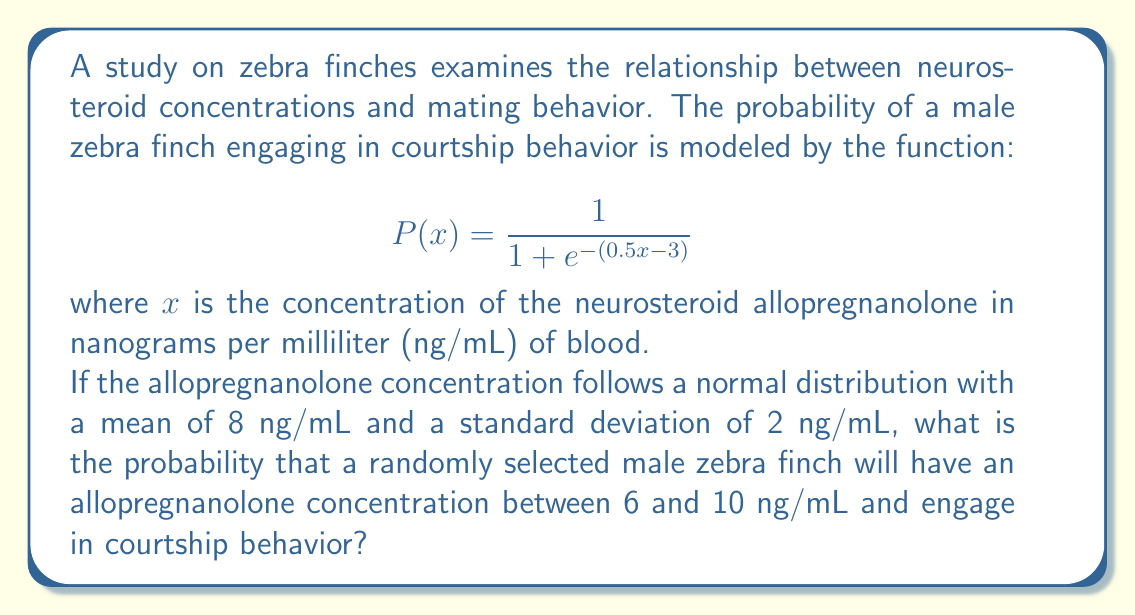Help me with this question. To solve this problem, we need to break it down into steps:

1) First, we need to find the probability that the allopregnanolone concentration is between 6 and 10 ng/mL.

2) Then, we need to calculate the probability of courtship behavior for concentrations of 6 and 10 ng/mL.

3) Finally, we'll use these probabilities to estimate the overall probability.

Step 1: Probability of concentration between 6 and 10 ng/mL

For a normal distribution, we can use the z-score formula:
$$z = \frac{x - \mu}{\sigma}$$

For x = 6: $z_1 = \frac{6 - 8}{2} = -1$
For x = 10: $z_2 = \frac{10 - 8}{2} = 1$

Using a standard normal distribution table or calculator:
P(-1 < Z < 1) ≈ 0.6827

Step 2: Probability of courtship behavior

For x = 6:
$$P(6) = \frac{1}{1 + e^{-(0.5 \cdot 6 - 3)}} \approx 0.5$$

For x = 10:
$$P(10) = \frac{1}{1 + e^{-(0.5 \cdot 10 - 3)}} \approx 0.9241$$

Step 3: Estimating overall probability

We can estimate the probability by taking the average of P(6) and P(10) and multiplying by the probability from step 1:

$$(\frac{0.5 + 0.9241}{2}) \cdot 0.6827 \approx 0.4865$$

This is an approximation, as the actual probability would involve integrating the product of the normal distribution and the logistic function over the interval [6, 10].
Answer: The approximate probability that a randomly selected male zebra finch will have an allopregnanolone concentration between 6 and 10 ng/mL and engage in courtship behavior is 0.4865 or about 48.65%. 